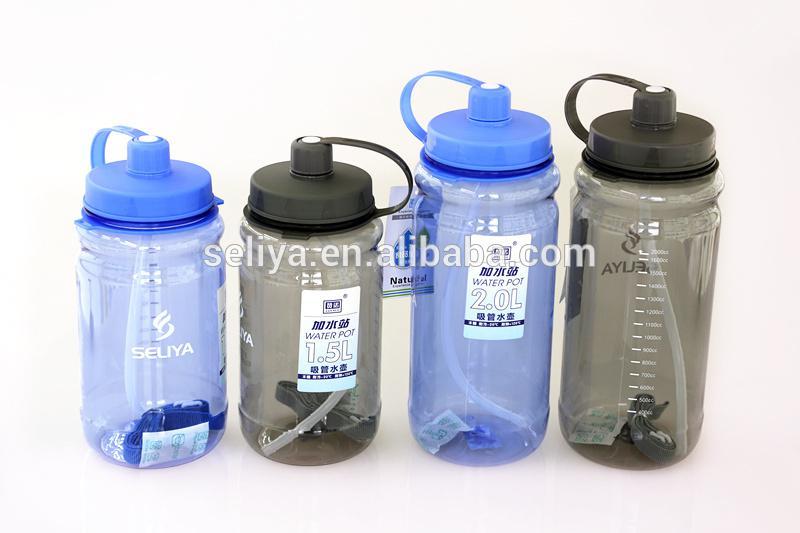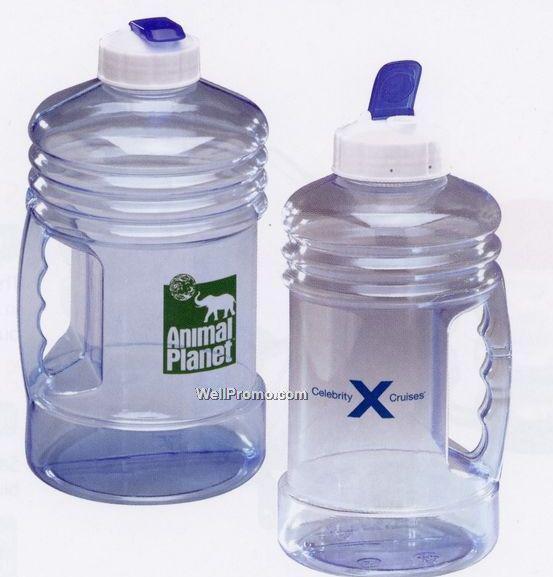The first image is the image on the left, the second image is the image on the right. Considering the images on both sides, is "The right image contains exactly three bottle containers arranged in a horizontal row." valid? Answer yes or no. No. The first image is the image on the left, the second image is the image on the right. Given the left and right images, does the statement "The left image includes two different-sized water bottles with blue caps that feature a side loop." hold true? Answer yes or no. Yes. 